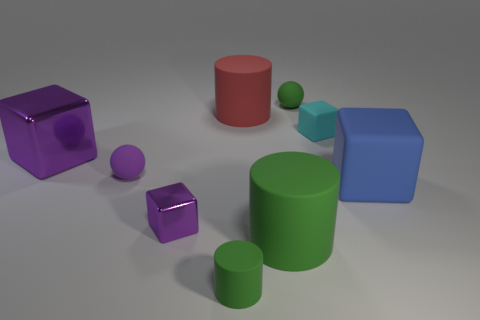What color is the tiny thing that is both in front of the blue rubber thing and to the left of the small green cylinder?
Make the answer very short. Purple. There is a purple block that is left of the small shiny object; what material is it?
Your answer should be compact. Metal. Is there another big matte object that has the same shape as the blue thing?
Ensure brevity in your answer.  No. How many other objects are there of the same shape as the large red thing?
Provide a short and direct response. 2. Is the shape of the tiny purple matte object the same as the purple metallic object that is in front of the large metallic block?
Keep it short and to the point. No. Are there any other things that are made of the same material as the small cyan cube?
Offer a very short reply. Yes. There is a large blue thing that is the same shape as the big purple object; what material is it?
Keep it short and to the point. Rubber. What number of big things are either cyan matte blocks or metallic cubes?
Provide a short and direct response. 1. Are there fewer small purple objects to the right of the big blue matte object than tiny purple cubes that are in front of the large green cylinder?
Offer a terse response. No. What number of objects are either blue objects or big cubes?
Make the answer very short. 2. 